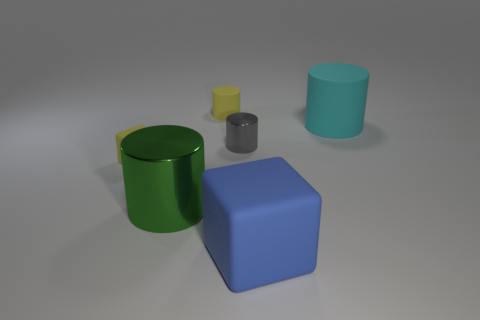There is a small yellow object that is in front of the gray shiny object; what shape is it?
Provide a short and direct response. Cube. There is a cyan thing that is the same size as the green metallic thing; what shape is it?
Keep it short and to the point. Cylinder. Is there a big blue thing that has the same shape as the gray thing?
Your answer should be compact. No. There is a tiny thing left of the green shiny cylinder; is its shape the same as the large rubber object that is in front of the cyan rubber object?
Offer a terse response. Yes. There is a block that is the same size as the cyan rubber cylinder; what is its material?
Make the answer very short. Rubber. What number of other things are the same material as the yellow block?
Provide a short and direct response. 3. The tiny yellow thing that is in front of the cylinder that is on the right side of the blue cube is what shape?
Your answer should be compact. Cube. What number of objects are big blue things or things in front of the cyan rubber cylinder?
Offer a very short reply. 4. What number of other things are there of the same color as the small rubber block?
Make the answer very short. 1. What number of red objects are blocks or spheres?
Your answer should be very brief. 0. 